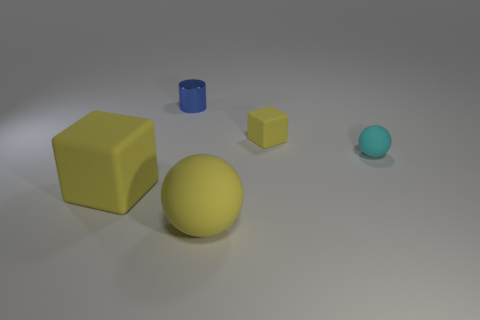How would you describe the material properties of the objects? The objects seem to have different material properties. The large yellow sphere and the two blocks have a matte finish, indicating they could be made of rubber or a similar non-reflective material. The smaller blue cylinder has a slightly glossy surface, suggesting it could be plastic or metal. The smallest sphere has a smooth surface with a slight reflection, hinting it might be made of glass or polished stone. 